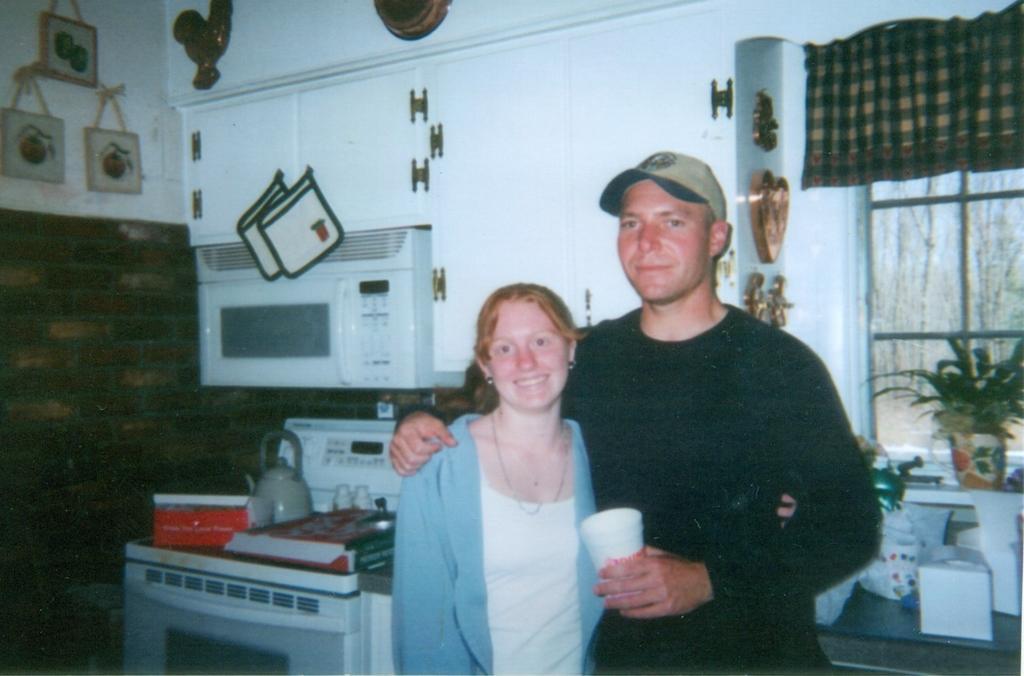Describe this image in one or two sentences. In this picture we can see a man holding a cup and standing. There is a woman standing. We can see a kettle, box and a book on a washing machine on the left side. There are few clothes on a cupboard. We can see a box and a houseplant on the shelf on the right side. We can see an oven and some other objects on the wall. There are few tree trunks in the background. 